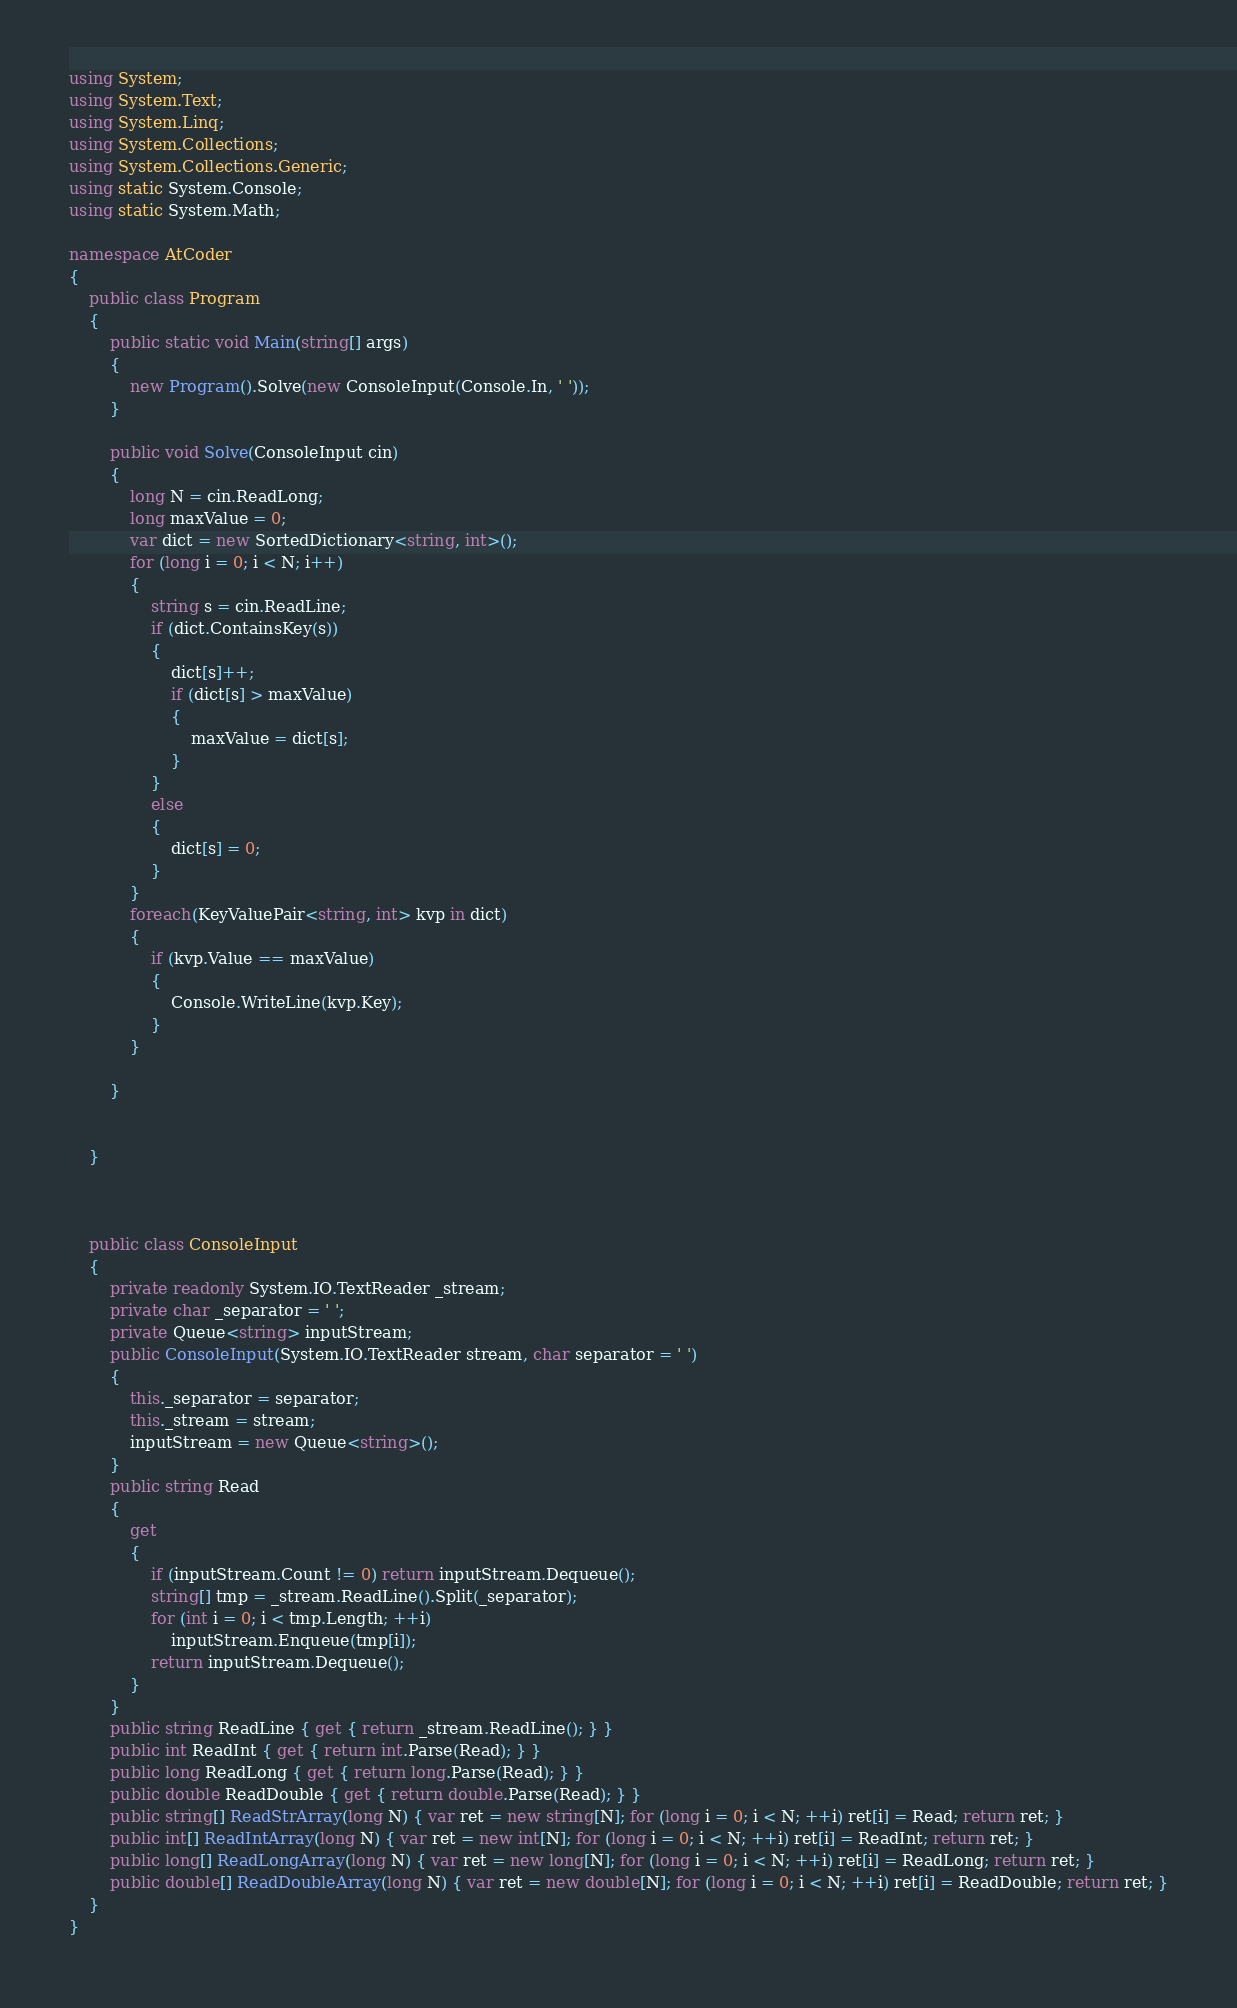<code> <loc_0><loc_0><loc_500><loc_500><_C#_>using System;
using System.Text;
using System.Linq;
using System.Collections;
using System.Collections.Generic;
using static System.Console;
using static System.Math;

namespace AtCoder
{
    public class Program
    {
        public static void Main(string[] args)
        {
            new Program().Solve(new ConsoleInput(Console.In, ' '));
        }

        public void Solve(ConsoleInput cin)
        {
            long N = cin.ReadLong;
            long maxValue = 0;
            var dict = new SortedDictionary<string, int>();
            for (long i = 0; i < N; i++)
            {
                string s = cin.ReadLine;
                if (dict.ContainsKey(s))
                {
                    dict[s]++;
                    if (dict[s] > maxValue)
                    {
                        maxValue = dict[s];
                    }
                }
                else
                {
                    dict[s] = 0;
                }
            }
            foreach(KeyValuePair<string, int> kvp in dict)
            {
                if (kvp.Value == maxValue)
                {
                    Console.WriteLine(kvp.Key);
                }
            }
            
        }


    }
            


    public class ConsoleInput
    {
        private readonly System.IO.TextReader _stream;
        private char _separator = ' ';
        private Queue<string> inputStream;
        public ConsoleInput(System.IO.TextReader stream, char separator = ' ')
        {
            this._separator = separator;
            this._stream = stream;
            inputStream = new Queue<string>();
        }
        public string Read
        {
            get
            {
                if (inputStream.Count != 0) return inputStream.Dequeue();
                string[] tmp = _stream.ReadLine().Split(_separator);
                for (int i = 0; i < tmp.Length; ++i)
                    inputStream.Enqueue(tmp[i]);
                return inputStream.Dequeue();
            }
        }
        public string ReadLine { get { return _stream.ReadLine(); } }
        public int ReadInt { get { return int.Parse(Read); } }
        public long ReadLong { get { return long.Parse(Read); } }
        public double ReadDouble { get { return double.Parse(Read); } }
        public string[] ReadStrArray(long N) { var ret = new string[N]; for (long i = 0; i < N; ++i) ret[i] = Read; return ret; }
        public int[] ReadIntArray(long N) { var ret = new int[N]; for (long i = 0; i < N; ++i) ret[i] = ReadInt; return ret; }
        public long[] ReadLongArray(long N) { var ret = new long[N]; for (long i = 0; i < N; ++i) ret[i] = ReadLong; return ret; }
        public double[] ReadDoubleArray(long N) { var ret = new double[N]; for (long i = 0; i < N; ++i) ret[i] = ReadDouble; return ret; }
    }
}
</code> 